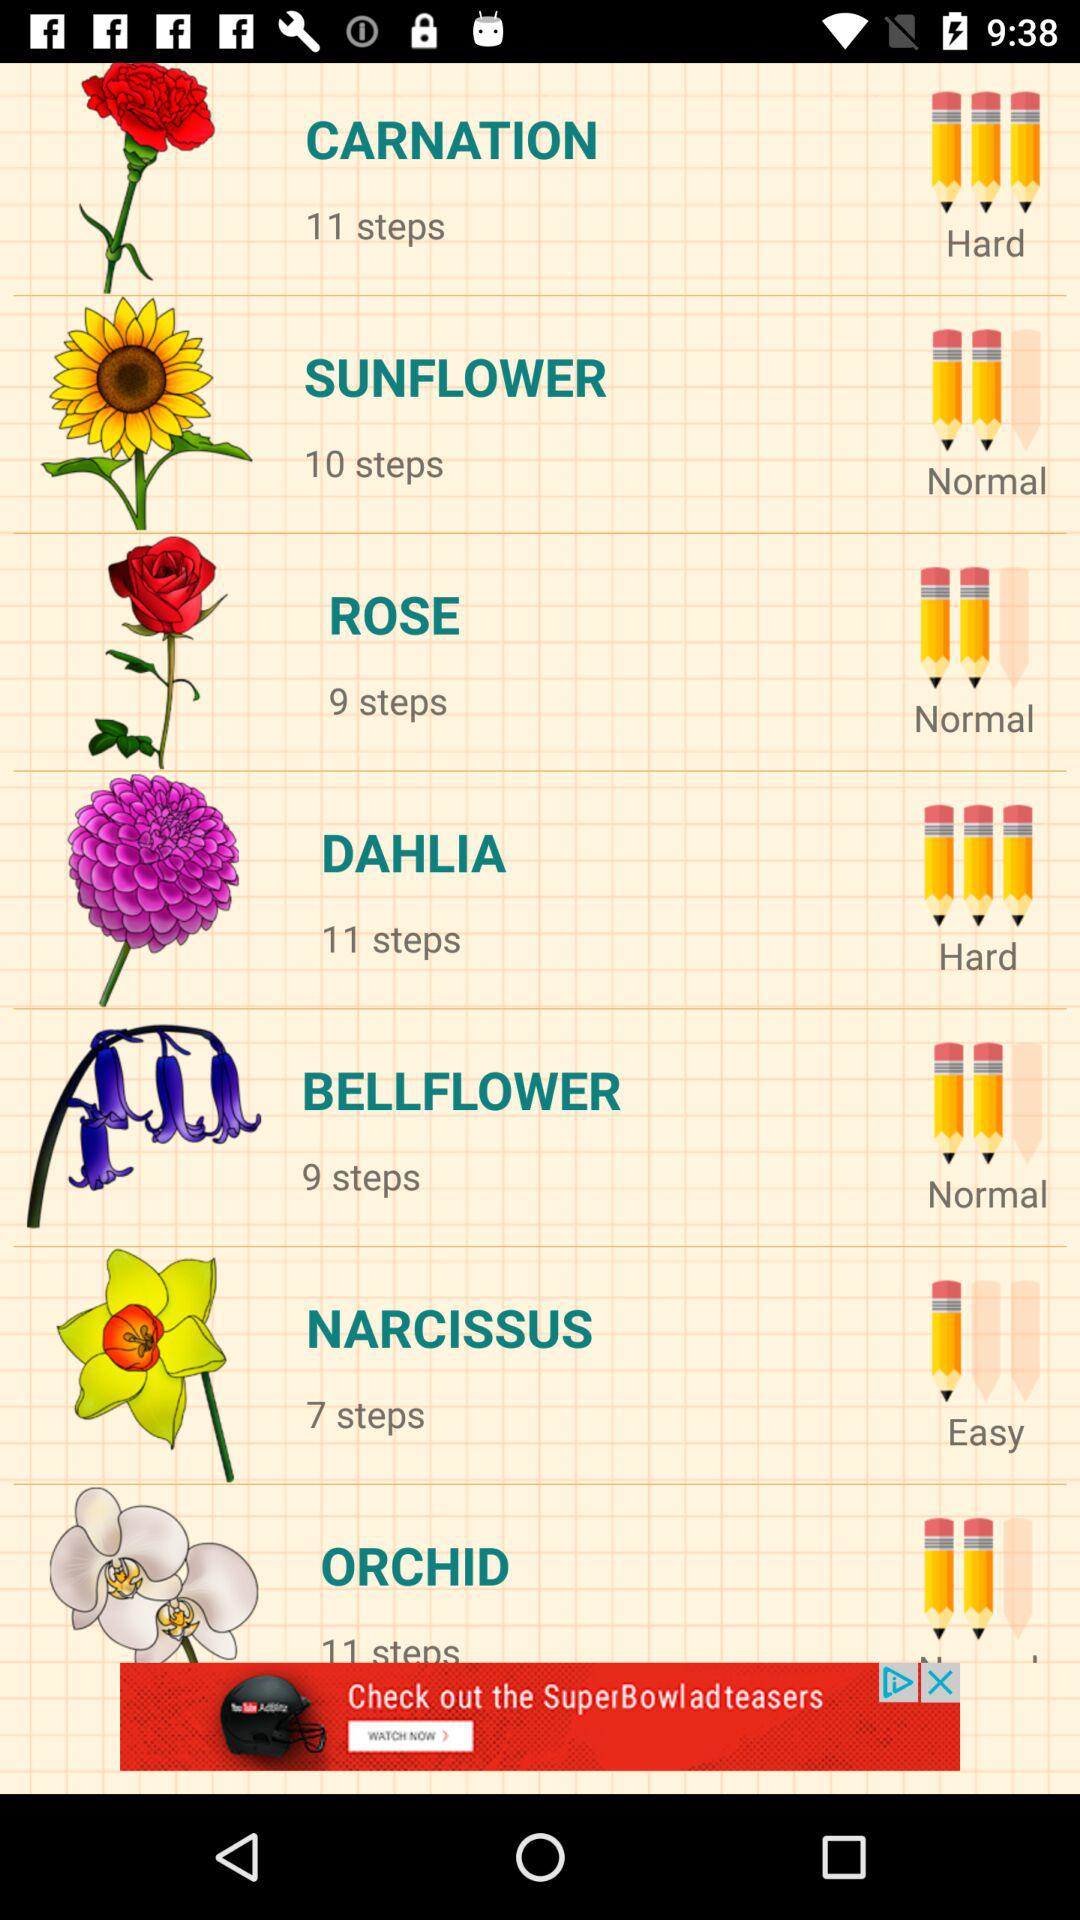What is the number of steps to draw the sunflower? The number of steps to draw the sunflower is 10. 